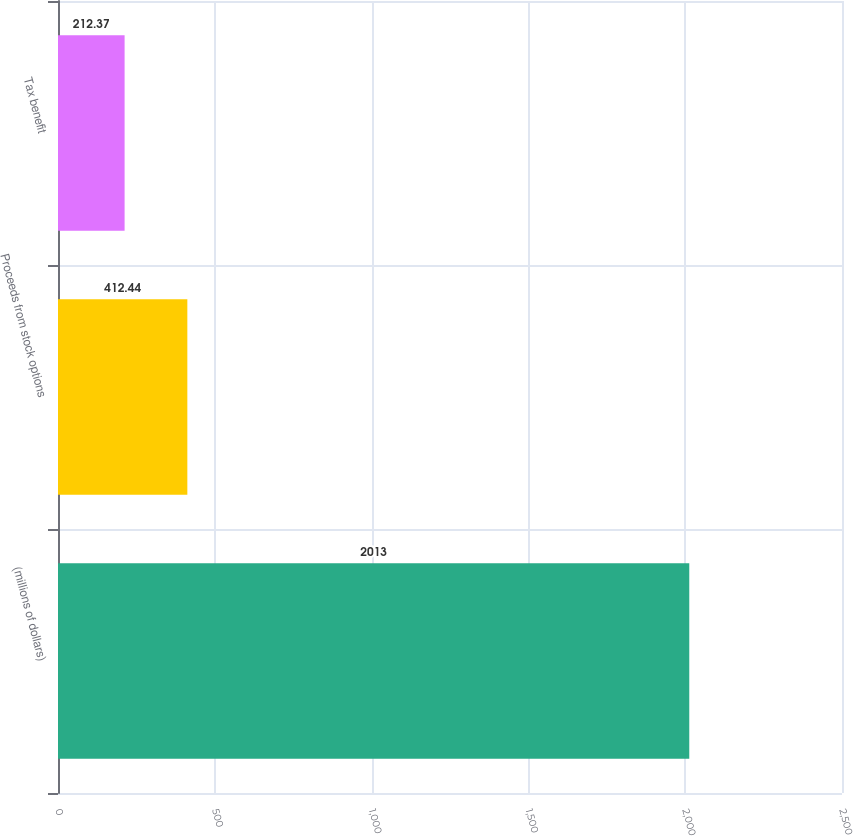<chart> <loc_0><loc_0><loc_500><loc_500><bar_chart><fcel>(millions of dollars)<fcel>Proceeds from stock options<fcel>Tax benefit<nl><fcel>2013<fcel>412.44<fcel>212.37<nl></chart> 